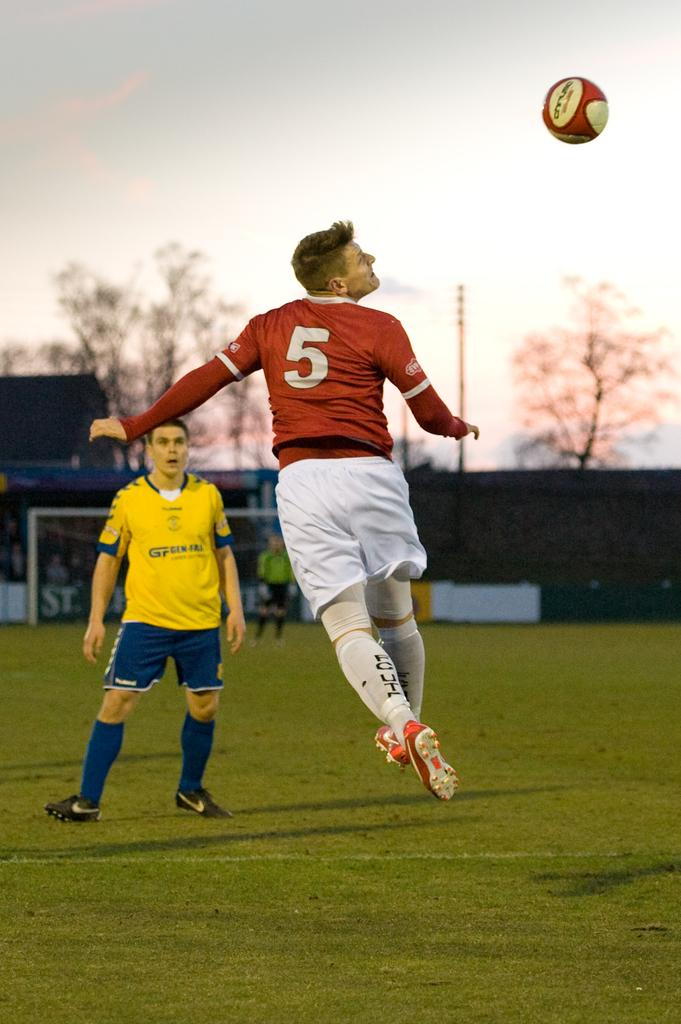<image>
Give a short and clear explanation of the subsequent image. A player wearing 5 is about to attempt a header in soccer 